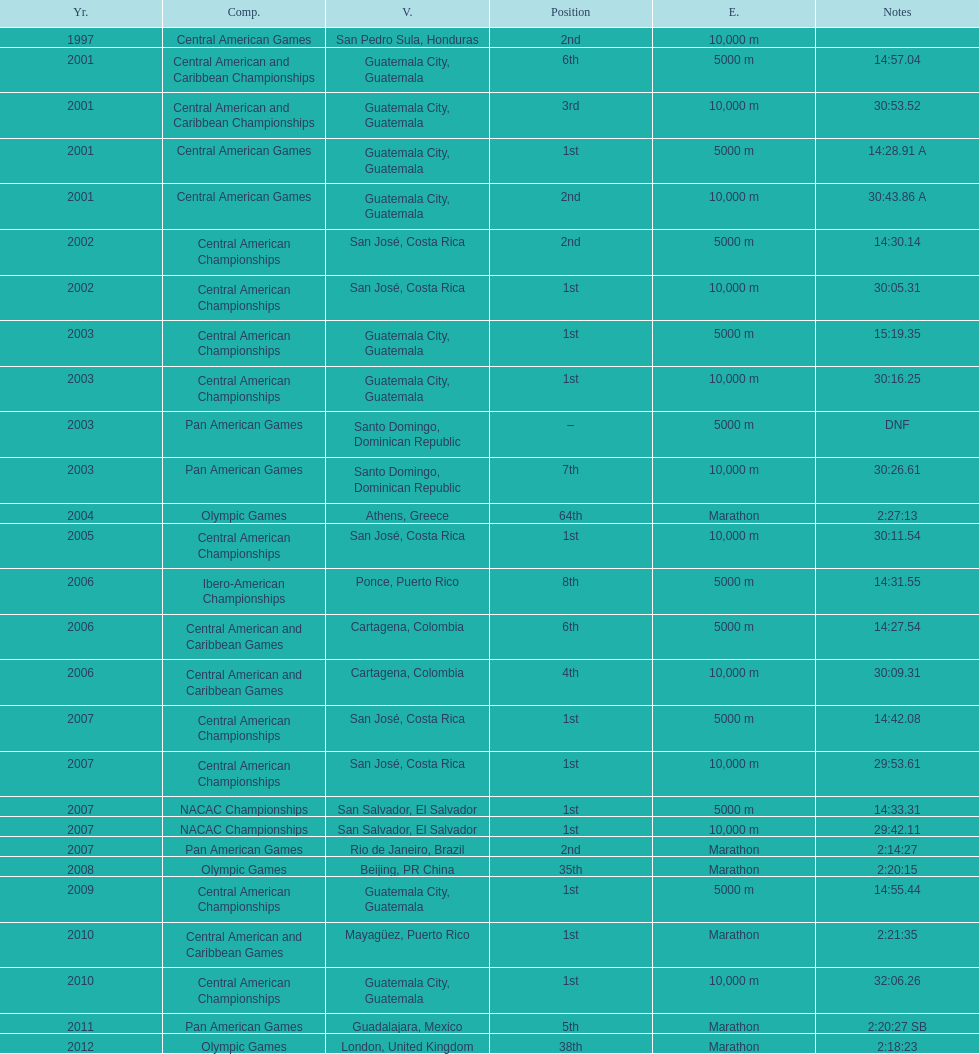Which event is listed more between the 10,000m and the 5000m? 10,000 m. 